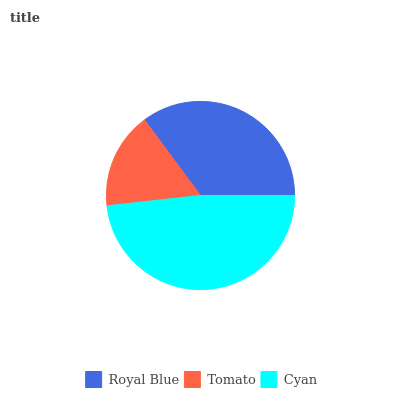Is Tomato the minimum?
Answer yes or no. Yes. Is Cyan the maximum?
Answer yes or no. Yes. Is Cyan the minimum?
Answer yes or no. No. Is Tomato the maximum?
Answer yes or no. No. Is Cyan greater than Tomato?
Answer yes or no. Yes. Is Tomato less than Cyan?
Answer yes or no. Yes. Is Tomato greater than Cyan?
Answer yes or no. No. Is Cyan less than Tomato?
Answer yes or no. No. Is Royal Blue the high median?
Answer yes or no. Yes. Is Royal Blue the low median?
Answer yes or no. Yes. Is Tomato the high median?
Answer yes or no. No. Is Cyan the low median?
Answer yes or no. No. 